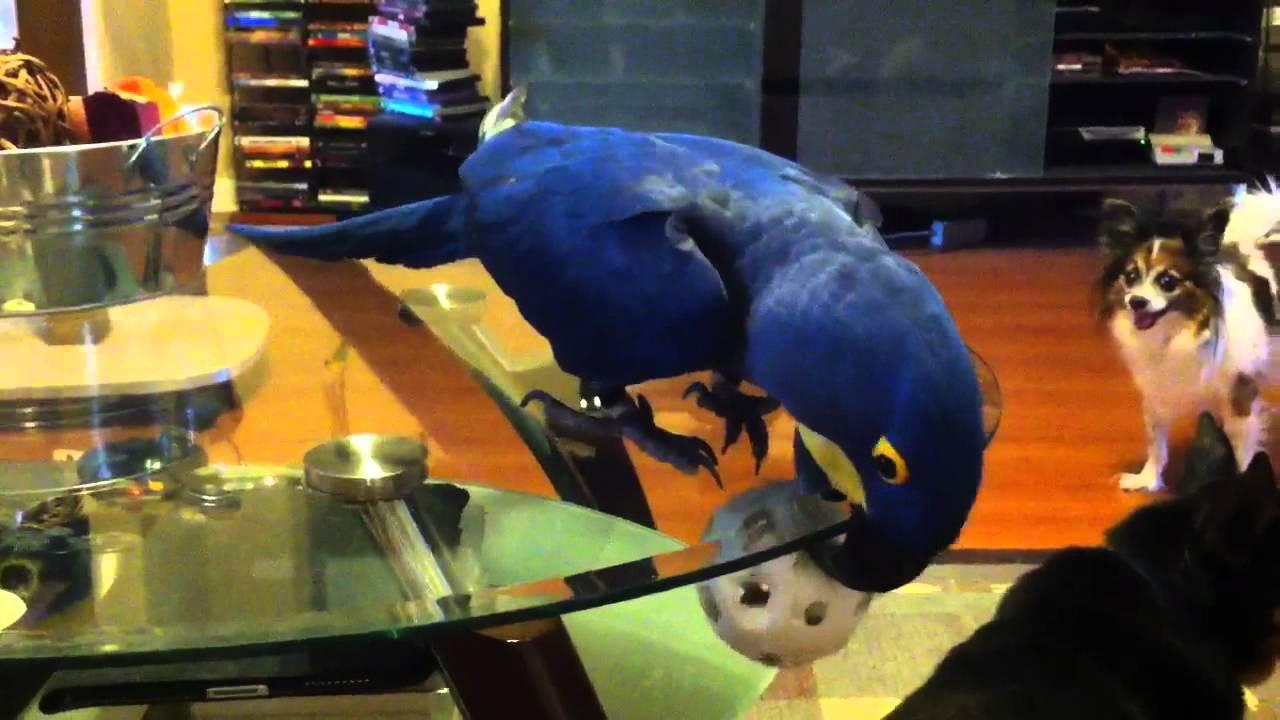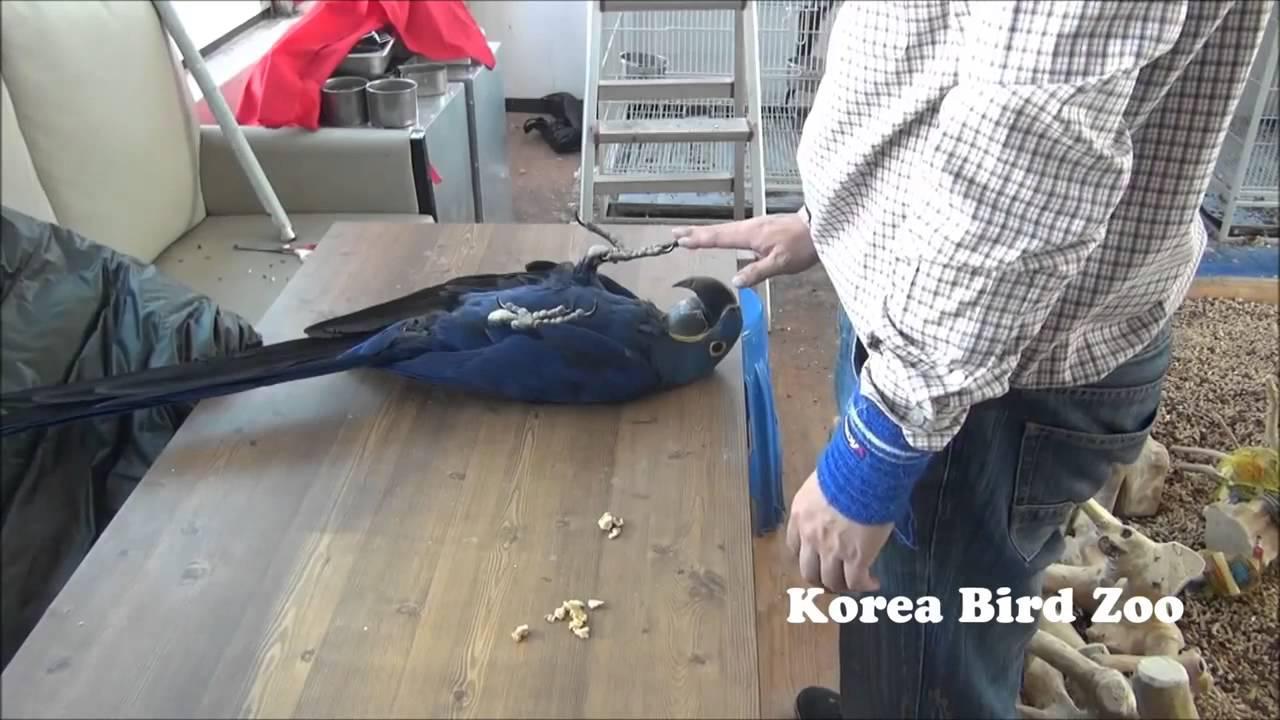The first image is the image on the left, the second image is the image on the right. Analyze the images presented: Is the assertion "There is a human petting a bird in at least one of the images." valid? Answer yes or no. Yes. The first image is the image on the left, the second image is the image on the right. Considering the images on both sides, is "At least one image shows a person touching a parrot that is on its back." valid? Answer yes or no. Yes. 